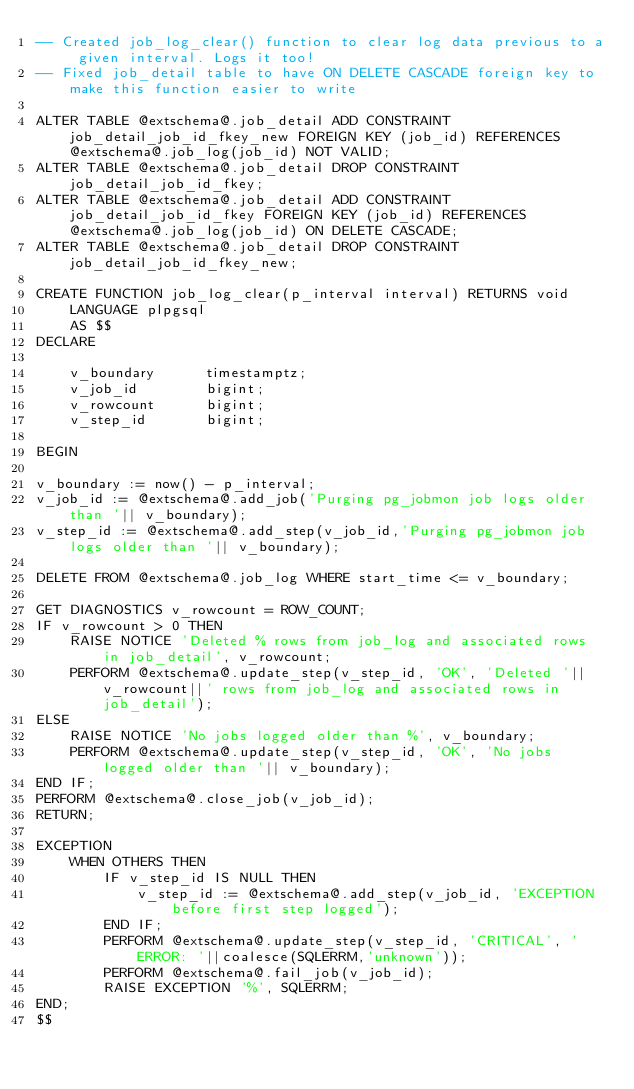<code> <loc_0><loc_0><loc_500><loc_500><_SQL_>-- Created job_log_clear() function to clear log data previous to a given interval. Logs it too!
-- Fixed job_detail table to have ON DELETE CASCADE foreign key to make this function easier to write

ALTER TABLE @extschema@.job_detail ADD CONSTRAINT job_detail_job_id_fkey_new FOREIGN KEY (job_id) REFERENCES @extschema@.job_log(job_id) NOT VALID;
ALTER TABLE @extschema@.job_detail DROP CONSTRAINT job_detail_job_id_fkey;
ALTER TABLE @extschema@.job_detail ADD CONSTRAINT job_detail_job_id_fkey FOREIGN KEY (job_id) REFERENCES @extschema@.job_log(job_id) ON DELETE CASCADE;
ALTER TABLE @extschema@.job_detail DROP CONSTRAINT job_detail_job_id_fkey_new;

CREATE FUNCTION job_log_clear(p_interval interval) RETURNS void
    LANGUAGE plpgsql
    AS $$
DECLARE
    
    v_boundary      timestamptz;
    v_job_id        bigint;
    v_rowcount      bigint;
    v_step_id       bigint;

BEGIN

v_boundary := now() - p_interval;
v_job_id := @extschema@.add_job('Purging pg_jobmon job logs older than '|| v_boundary);
v_step_id := @extschema@.add_step(v_job_id,'Purging pg_jobmon job logs older than '|| v_boundary);

DELETE FROM @extschema@.job_log WHERE start_time <= v_boundary;

GET DIAGNOSTICS v_rowcount = ROW_COUNT;
IF v_rowcount > 0 THEN
    RAISE NOTICE 'Deleted % rows from job_log and associated rows in job_detail', v_rowcount;
    PERFORM @extschema@.update_step(v_step_id, 'OK', 'Deleted '||v_rowcount||' rows from job_log and associated rows in job_detail');
ELSE
    RAISE NOTICE 'No jobs logged older than %', v_boundary;
    PERFORM @extschema@.update_step(v_step_id, 'OK', 'No jobs logged older than '|| v_boundary);
END IF;
PERFORM @extschema@.close_job(v_job_id);
RETURN;

EXCEPTION
    WHEN OTHERS THEN
        IF v_step_id IS NULL THEN
            v_step_id := @extschema@.add_step(v_job_id, 'EXCEPTION before first step logged');
        END IF;
        PERFORM @extschema@.update_step(v_step_id, 'CRITICAL', 'ERROR: '||coalesce(SQLERRM,'unknown'));
        PERFORM @extschema@.fail_job(v_job_id);
        RAISE EXCEPTION '%', SQLERRM;
END;
$$ 
</code> 